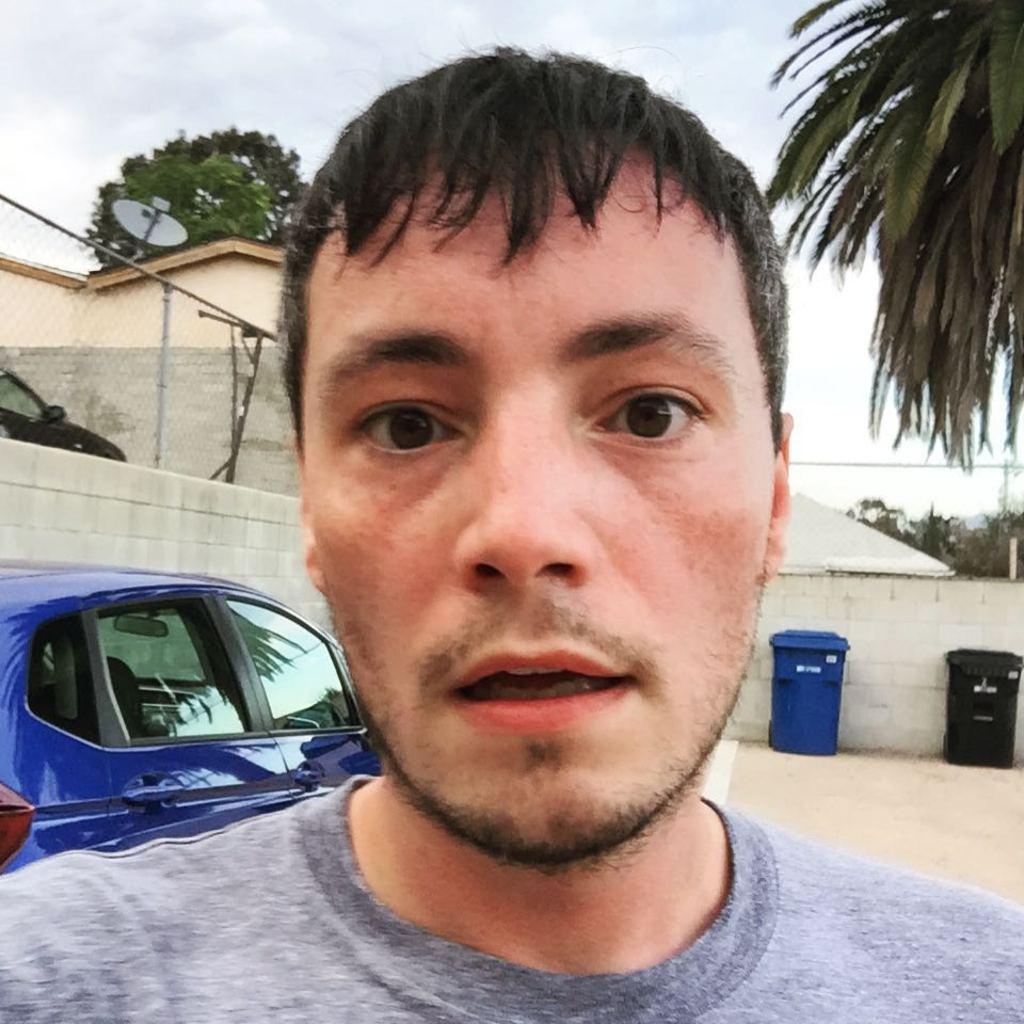Could you give a brief overview of what you see in this image? In this image there is a man. Behind the man there is a blue color car. Image also consists of trash bins, fence, antenna and many trees. In the background there are houses. Wall and ground is visible. At the top there is sky with clouds. 